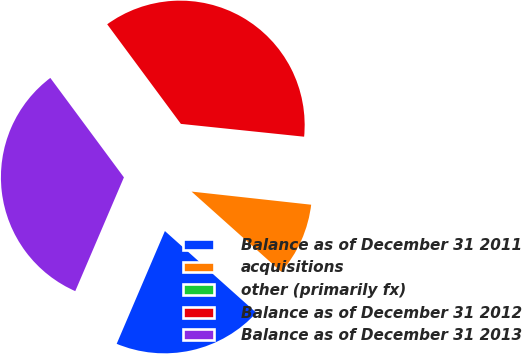Convert chart to OTSL. <chart><loc_0><loc_0><loc_500><loc_500><pie_chart><fcel>Balance as of December 31 2011<fcel>acquisitions<fcel>other (primarily fx)<fcel>Balance as of December 31 2012<fcel>Balance as of December 31 2013<nl><fcel>19.82%<fcel>9.87%<fcel>0.09%<fcel>36.79%<fcel>33.43%<nl></chart> 